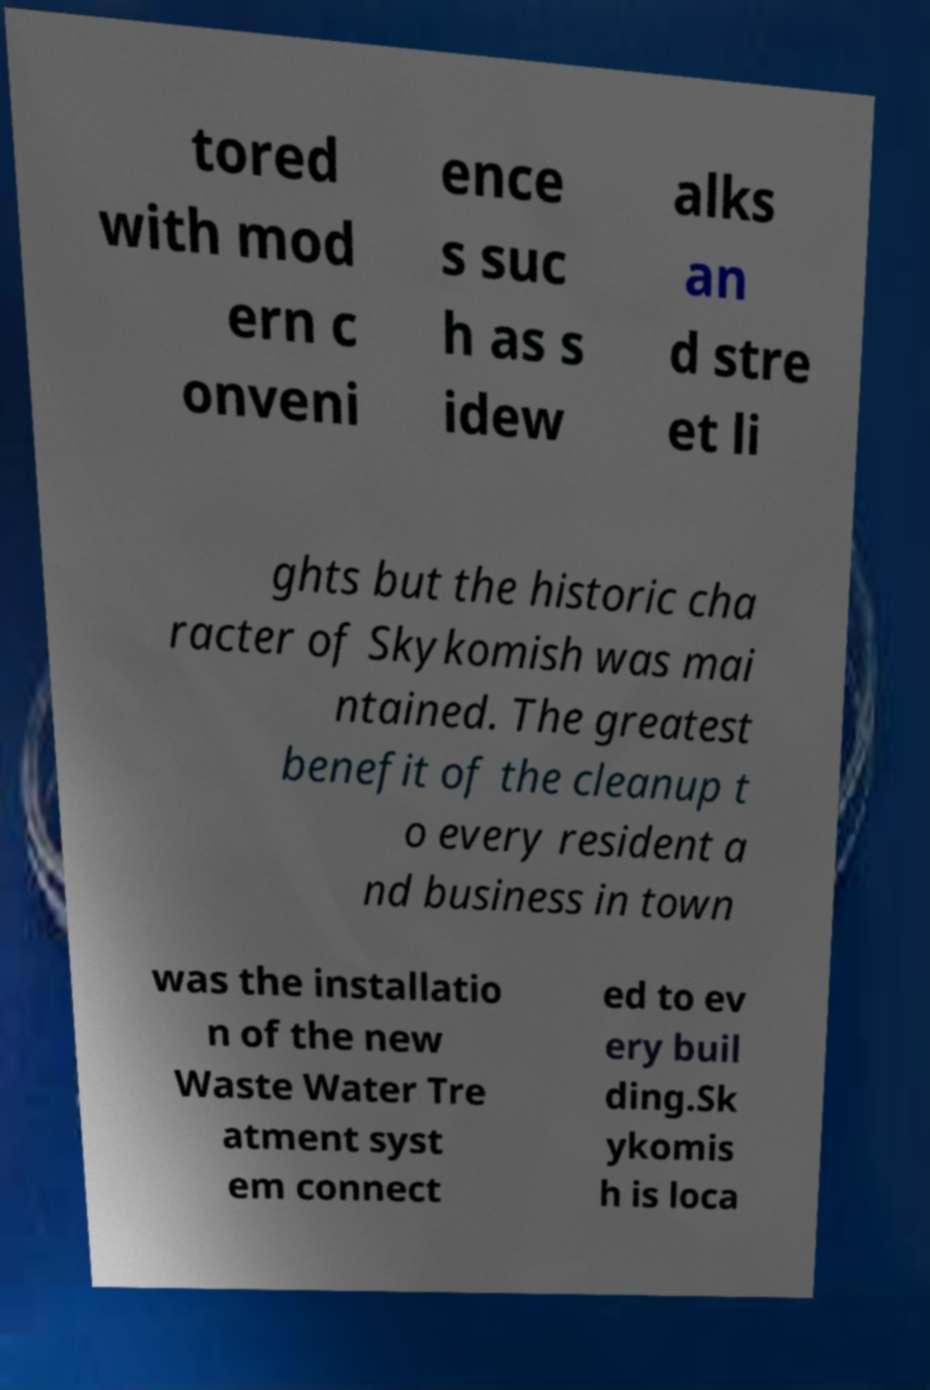Could you assist in decoding the text presented in this image and type it out clearly? tored with mod ern c onveni ence s suc h as s idew alks an d stre et li ghts but the historic cha racter of Skykomish was mai ntained. The greatest benefit of the cleanup t o every resident a nd business in town was the installatio n of the new Waste Water Tre atment syst em connect ed to ev ery buil ding.Sk ykomis h is loca 